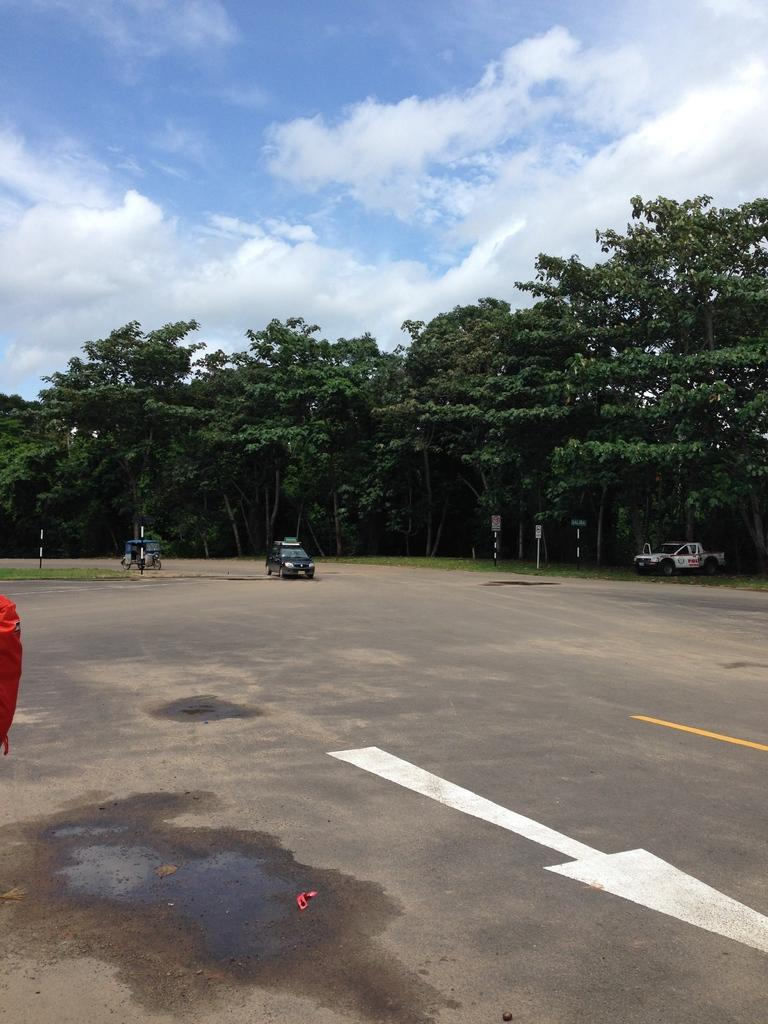What is the main feature of the image? There is a road in the image. What else can be seen on the road? There are vehicles in the image. What objects are present alongside the road? There are boards and poles in the image. What type of natural elements are visible in the image? There are trees in the image. What is visible in the background of the image? The sky is visible in the background of the image, and there are clouds in the sky. What type of appliance can be seen in the image? There is no appliance present in the image. What color are the eyes of the trees in the image? Trees do not have eyes, so this question cannot be answered. 